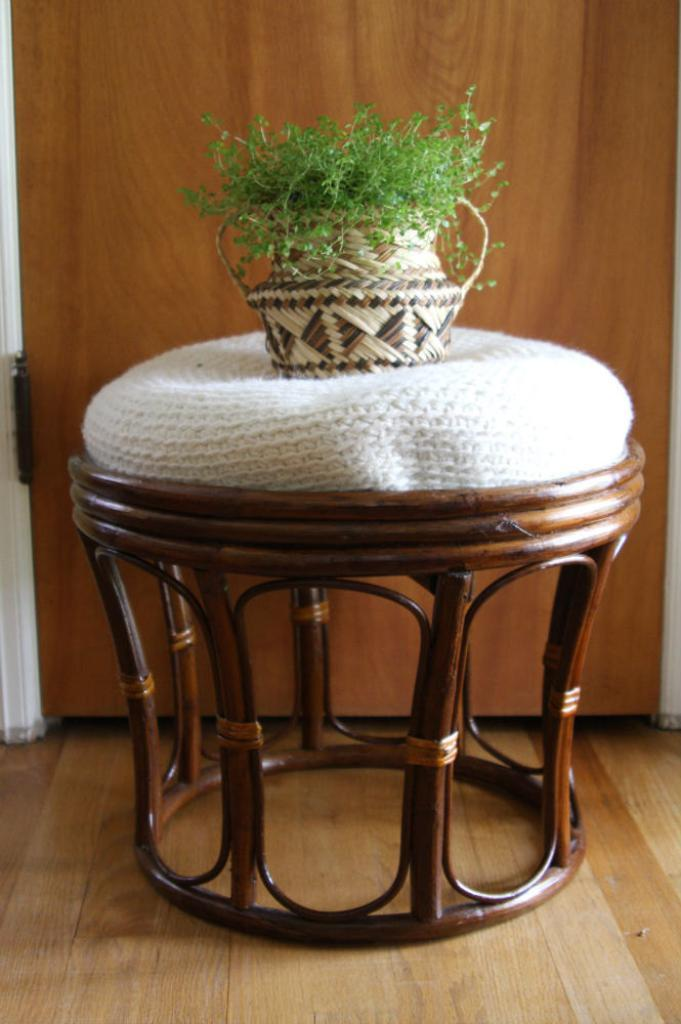What type of furniture is present in the image? There is a wooden table in the image. Where is the table located? The table is on the floor. What is placed on the table? There is a pillow-like object on the table. What is on top of the pillow-like object? There is a plant pot on the pillow-like object. What can be seen in the background of the image? There is a wooden door in the background of the image. How many guitars are being played by the bears in the image? There are no guitars or bears present in the image. 